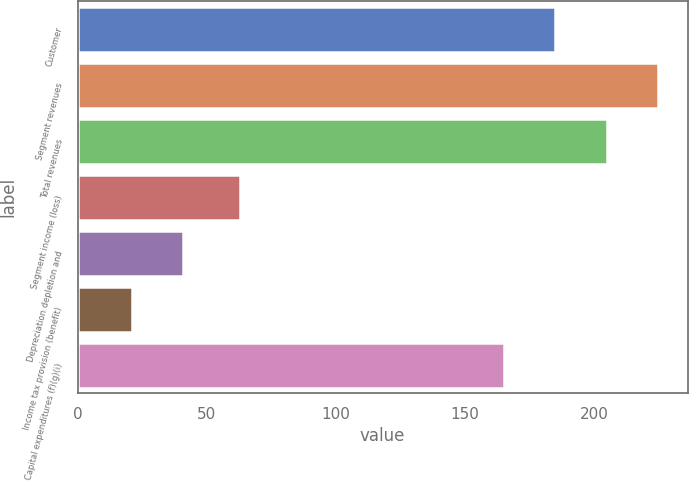<chart> <loc_0><loc_0><loc_500><loc_500><bar_chart><fcel>Customer<fcel>Segment revenues<fcel>Total revenues<fcel>Segment income (loss)<fcel>Depreciation depletion and<fcel>Income tax provision (benefit)<fcel>Capital expenditures (f)(g)(i)<nl><fcel>185<fcel>225<fcel>205<fcel>63<fcel>41<fcel>21<fcel>165<nl></chart> 